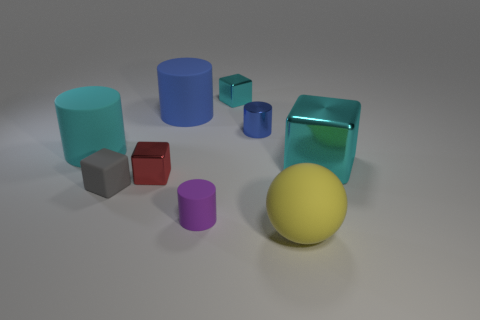Add 1 green rubber objects. How many objects exist? 10 Subtract all balls. How many objects are left? 8 Subtract all big blocks. Subtract all big yellow matte balls. How many objects are left? 7 Add 6 tiny red blocks. How many tiny red blocks are left? 7 Add 6 small cyan blocks. How many small cyan blocks exist? 7 Subtract 0 yellow cylinders. How many objects are left? 9 